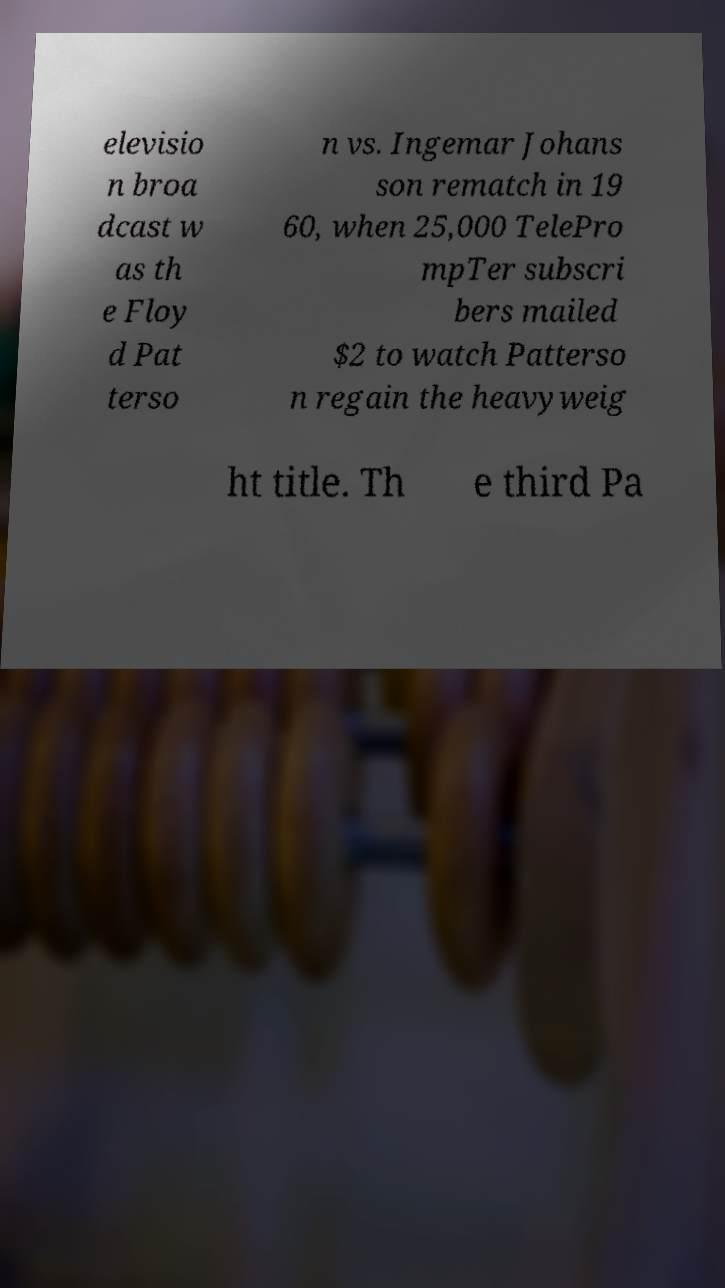Please identify and transcribe the text found in this image. elevisio n broa dcast w as th e Floy d Pat terso n vs. Ingemar Johans son rematch in 19 60, when 25,000 TelePro mpTer subscri bers mailed $2 to watch Patterso n regain the heavyweig ht title. Th e third Pa 